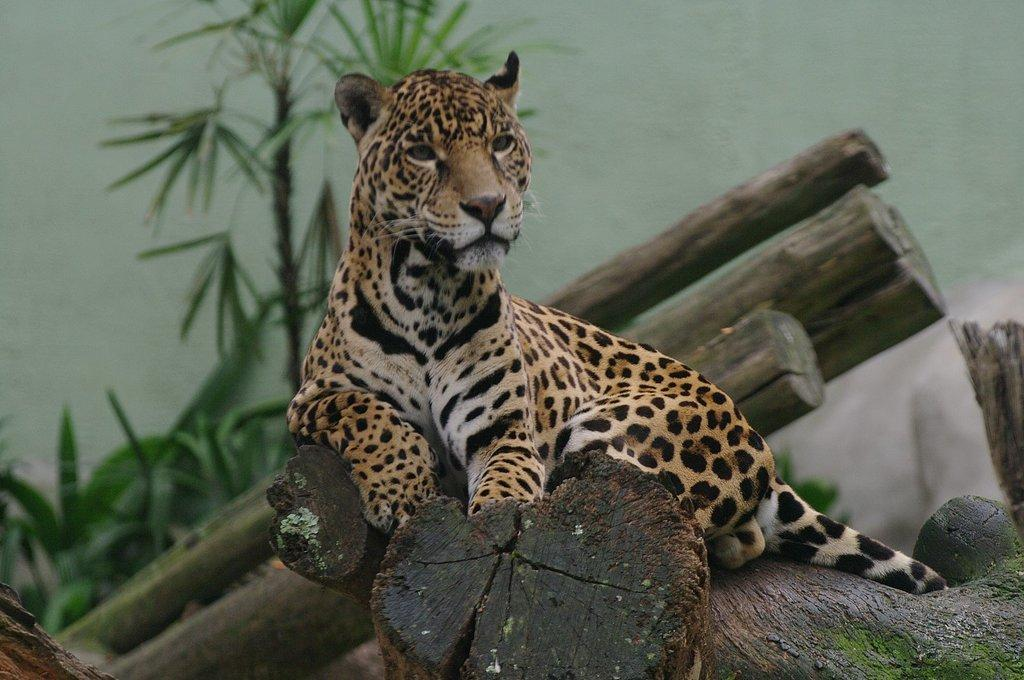What animal is the main subject of the image? There is a cheetah in the image. What is the cheetah doing in the image? The cheetah is sitting on a log. What can be seen in the background of the image? There are plants and a wall in the background of the image. What type of honey can be seen dripping from the cheetah's mouth in the image? There is no honey present in the image; the cheetah is simply sitting on a log. 